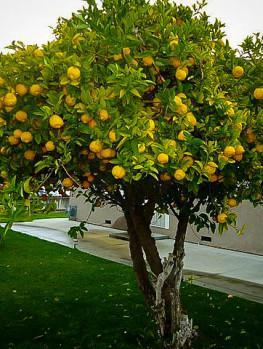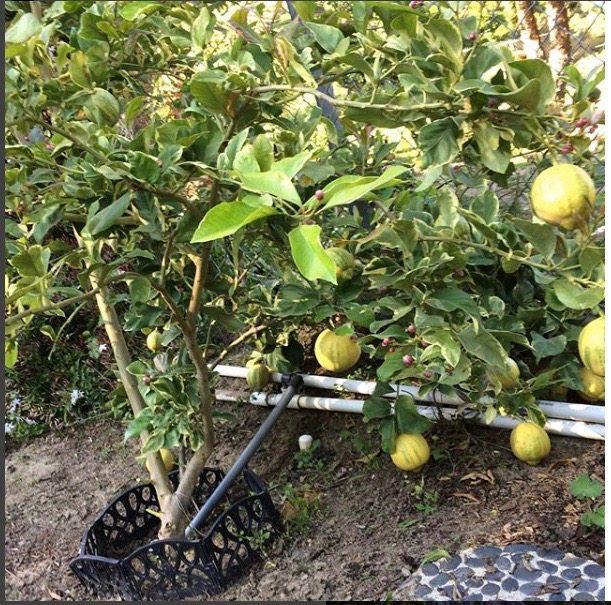The first image is the image on the left, the second image is the image on the right. Given the left and right images, does the statement "There are lemon trees in both images." hold true? Answer yes or no. Yes. 